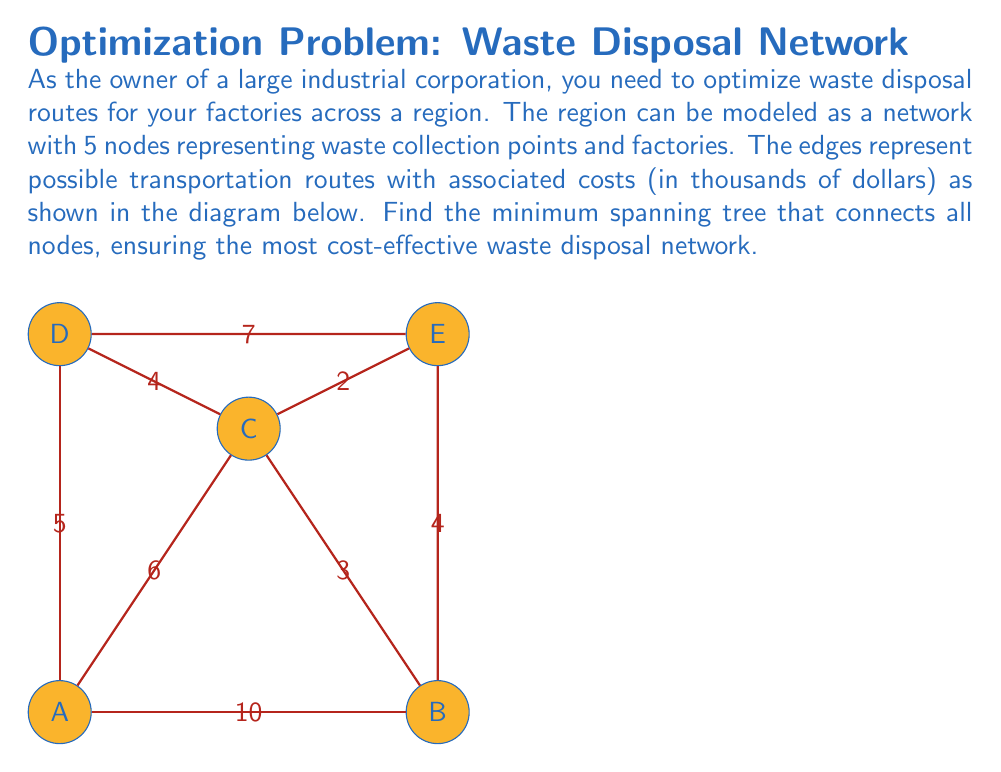Help me with this question. To find the minimum spanning tree, we can use Kruskal's algorithm:

1) Sort all edges by weight (cost) in ascending order:
   CE (2), BC (3), BE (4), CD (4), AD (5), AC (6), DE (7), AB (10)

2) Start with an empty set of edges and add edges one by one:
   a) Add CE (2)
   b) Add BC (3)
   c) Add BE (4) - forms a cycle, skip
   d) Add CD (4)
   e) Add AD (5)

3) We now have 4 edges connecting all 5 nodes, so we stop.

The minimum spanning tree consists of edges:
CE (2), BC (3), CD (4), and AD (5)

The total cost of this network is:
$$2 + 3 + 4 + 5 = 14$$ thousand dollars

This topological optimization ensures the most cost-effective waste disposal network, minimizing environmental impact while maximizing economic efficiency.
Answer: Minimum spanning tree: CE, BC, CD, AD; Total cost: $14,000 